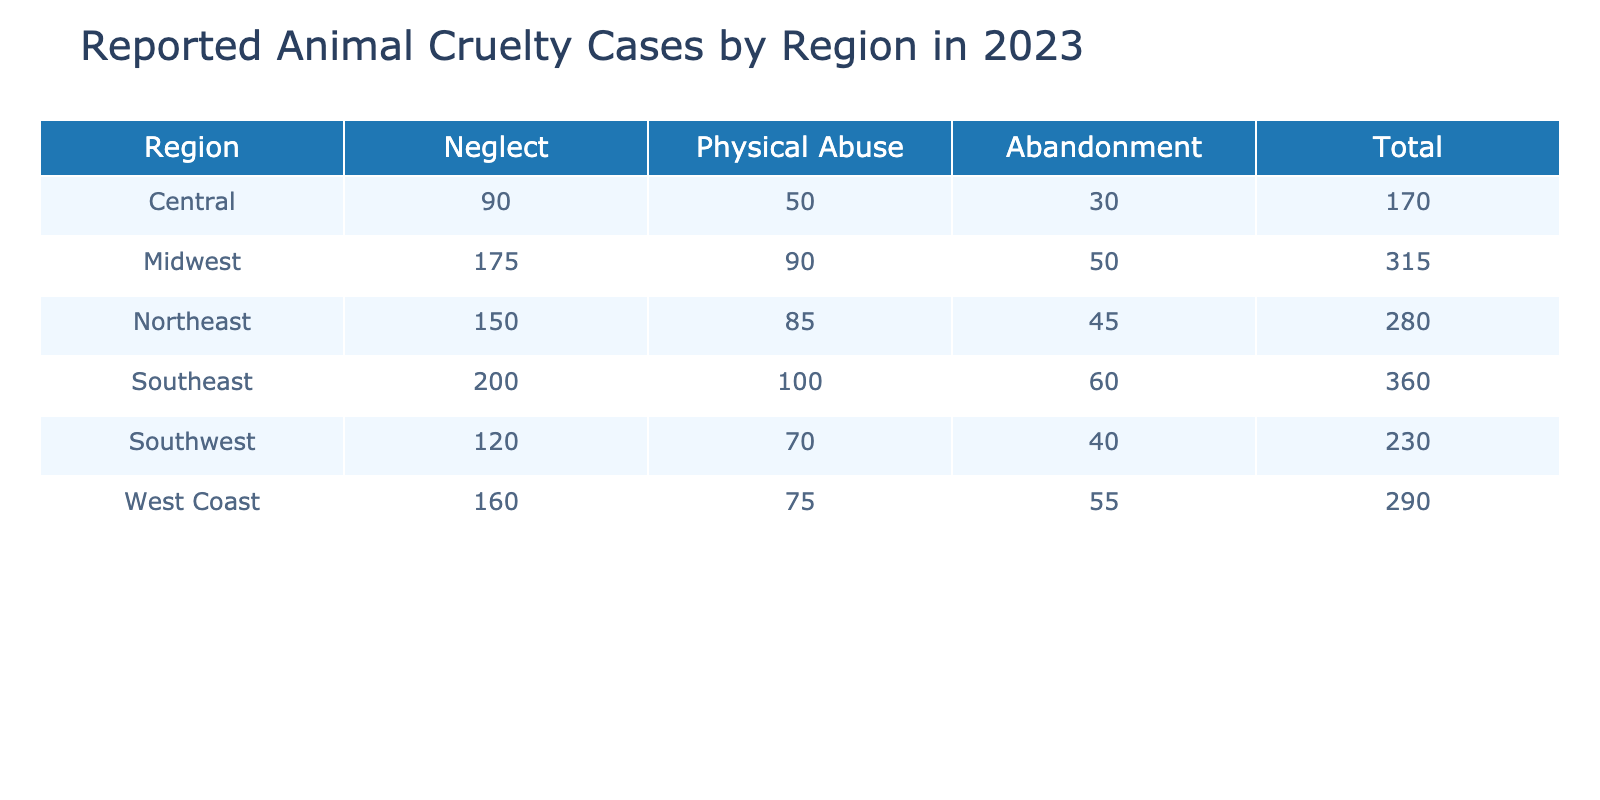What region reported the highest number of neglect cases? By reviewing the 'Neglect' column, the Southeast has 200 cases, which is the highest among all regions compared.
Answer: Southeast How many total animal cruelty cases were reported in the Midwest? The total for the Midwest is calculated by summing the reported cases in all categories: 175 (Neglect) + 90 (Physical Abuse) + 50 (Abandonment) = 315.
Answer: 315 Is there more physical abuse reported in the Southwest or the West Coast? In the Southwest, 70 physical abuse cases were reported, while the West Coast reported 75 cases. Since 75 is greater than 70, the West Coast has more.
Answer: West Coast What is the total number of reported abandonment cases across all regions? To find the total, sum the abandonment cases from each region: 45 (Northeast) + 60 (Southeast) + 50 (Midwest) + 40 (Southwest) + 55 (West Coast) + 30 (Central) = 280.
Answer: 280 Which type of abuse is the least reported in the Central region? In the Central region, the reported cases are 90 for Neglect, 50 for Physical Abuse, and 30 for Abandonment. The least number in that region is 30 for Abandonment.
Answer: Abandonment What is the average number of reported neglect cases across all regions? To find the average neglect cases: First, add all neglect cases: 150 + 200 + 175 + 120 + 160 + 90 = 995. Then divide by the number of regions (6), which gives 995 / 6 ≈ 165.83.
Answer: 165.83 Are there any regions with zero reported cases for any type of abuse? By checking all the reported cases, there are no regions with zero cases in any category; every region has reported cases for all types of abuse.
Answer: No Which region has the lowest total number of reported abuse cases? Calculate total cases for each region: Northeast (150 + 85 + 45 = 280), Southeast (200 + 100 + 60 = 360), Midwest (175 + 90 + 50 = 315), Southwest (120 + 70 + 40 = 230), West Coast (160 + 75 + 55 = 290), Central (90 + 50 + 30 = 170). Central has the lowest at 170.
Answer: Central 